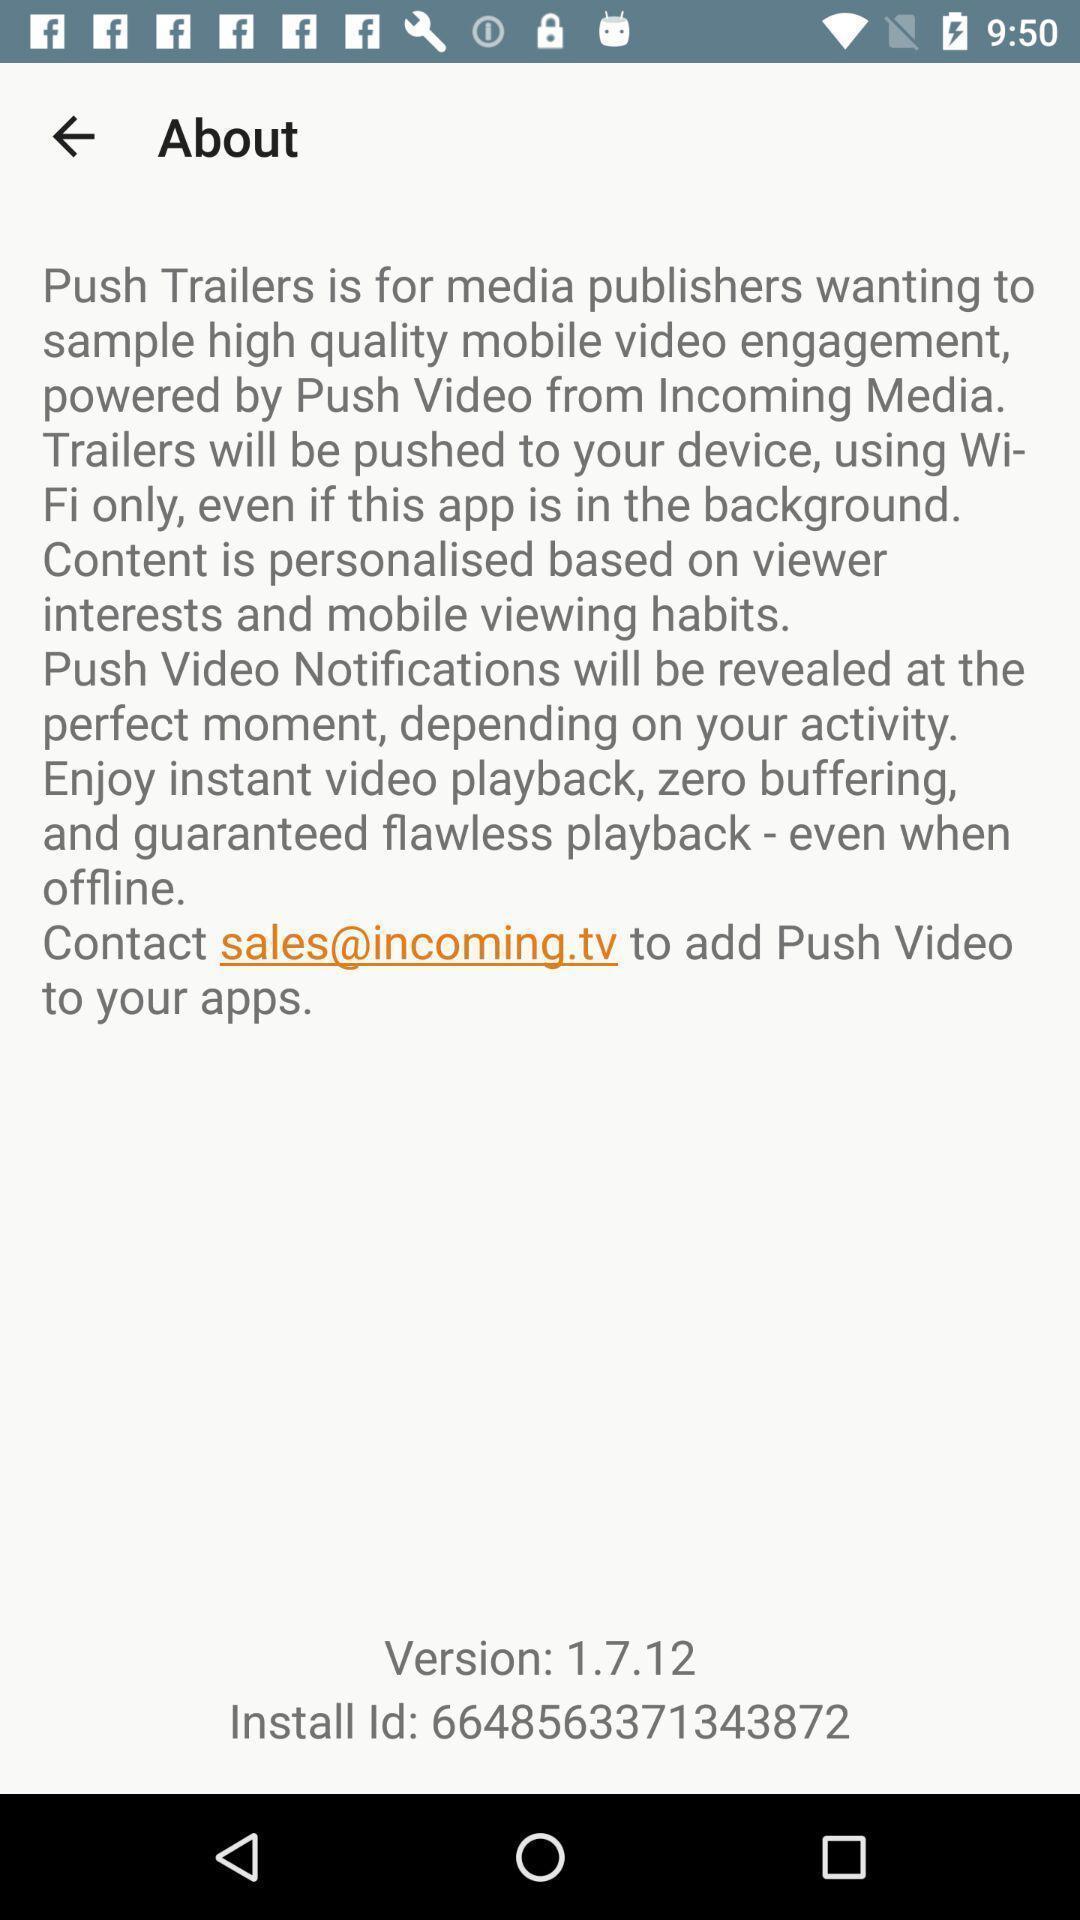What can you discern from this picture? Screen displaying information about an app. 